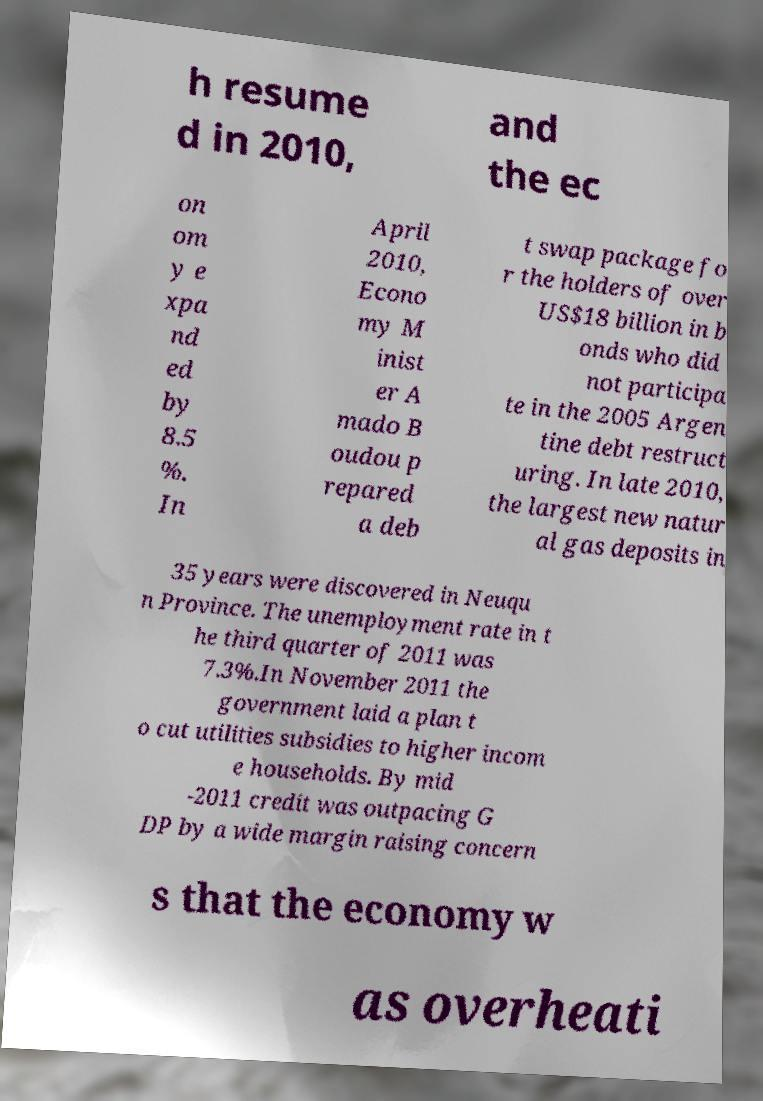Please read and relay the text visible in this image. What does it say? h resume d in 2010, and the ec on om y e xpa nd ed by 8.5 %. In April 2010, Econo my M inist er A mado B oudou p repared a deb t swap package fo r the holders of over US$18 billion in b onds who did not participa te in the 2005 Argen tine debt restruct uring. In late 2010, the largest new natur al gas deposits in 35 years were discovered in Neuqu n Province. The unemployment rate in t he third quarter of 2011 was 7.3%.In November 2011 the government laid a plan t o cut utilities subsidies to higher incom e households. By mid -2011 credit was outpacing G DP by a wide margin raising concern s that the economy w as overheati 